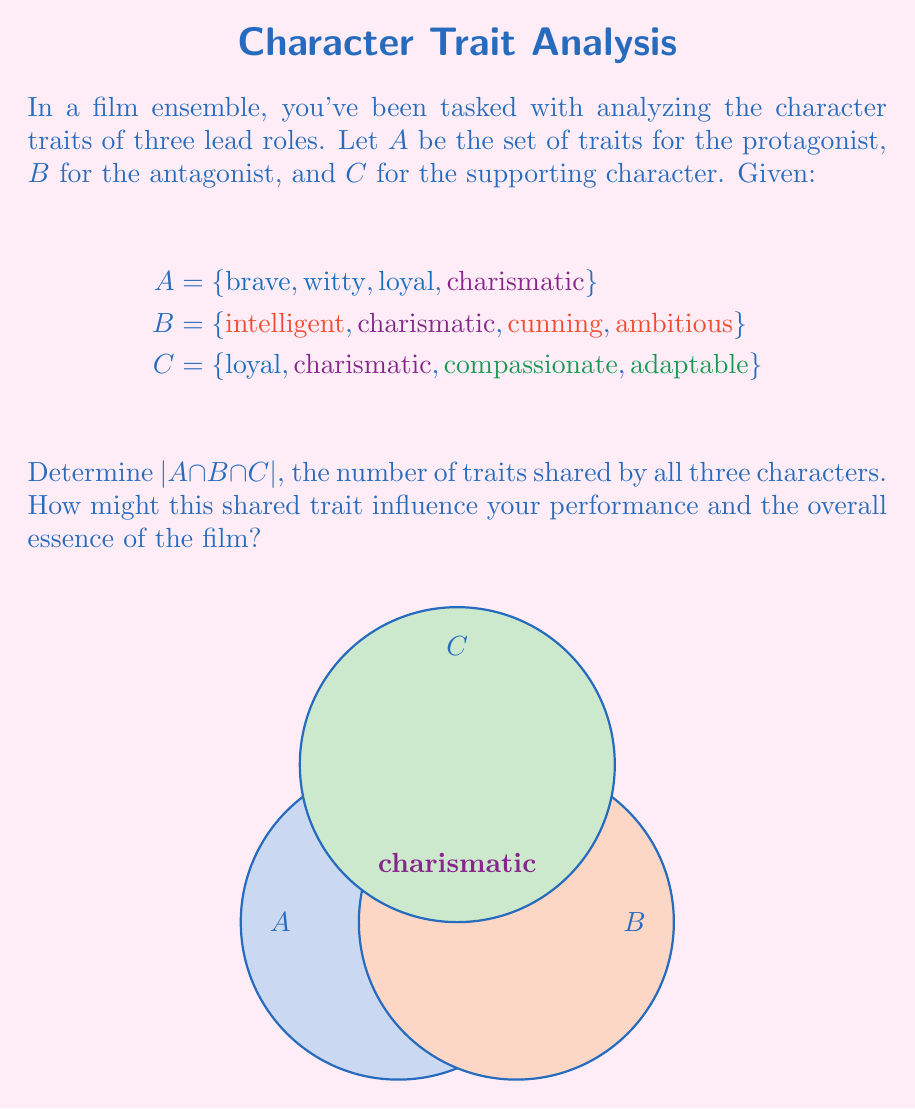Can you answer this question? To solve this problem, we need to follow these steps:

1) First, let's identify the elements in each set:
   A = {brave, witty, loyal, charismatic}
   B = {intelligent, charismatic, cunning, ambitious}
   C = {loyal, charismatic, compassionate, adaptable}

2) Now, we need to find the intersection of all three sets. This means identifying traits that appear in all three sets.

3) Let's compare the sets:
   - "brave", "witty" are unique to A
   - "intelligent", "cunning", "ambitious" are unique to B
   - "compassionate", "adaptable" are unique to C
   - "loyal" appears in A and C, but not in B
   - "charismatic" appears in all three sets

4) Therefore, the intersection of A, B, and C is:
   A ∩ B ∩ C = {charismatic}

5) The cardinality of this intersection, denoted by $|A \cap B \cap C|$, is the number of elements in this set.

6) $|A \cap B \cap C| = 1$

This shared trait of being charismatic could be a central theme in the film, influencing your performance by emphasizing this characteristic in each role you portray. It might also represent the essence of the film, suggesting that charisma is a key element in the story's dynamics and character interactions.
Answer: $|A \cap B \cap C| = 1$ 